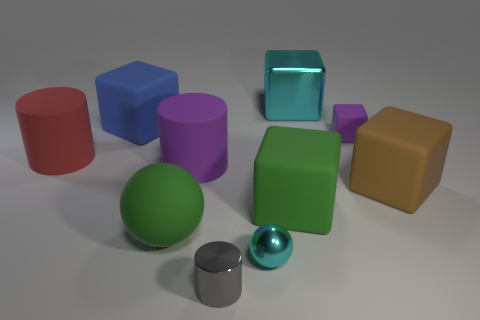Subtract all big cyan blocks. How many blocks are left? 4 Subtract all brown cubes. How many cubes are left? 4 Subtract all brown cubes. Subtract all green spheres. How many cubes are left? 4 Subtract all spheres. How many objects are left? 8 Subtract 0 gray spheres. How many objects are left? 10 Subtract all tiny gray balls. Subtract all large blue rubber objects. How many objects are left? 9 Add 4 small cylinders. How many small cylinders are left? 5 Add 7 tiny purple things. How many tiny purple things exist? 8 